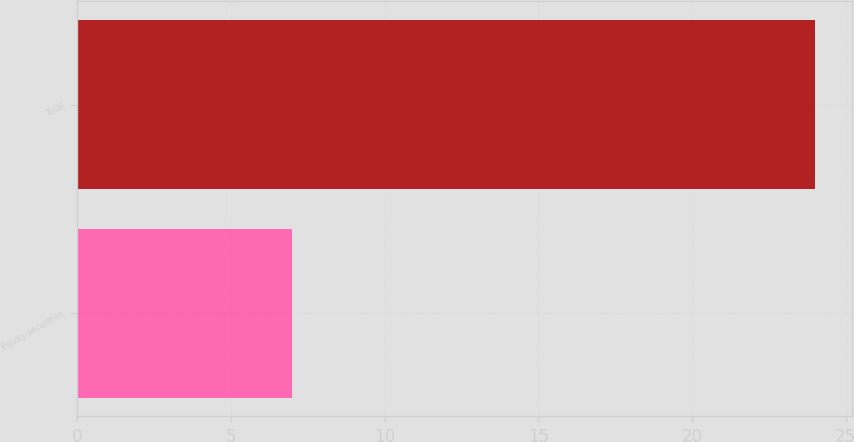Convert chart to OTSL. <chart><loc_0><loc_0><loc_500><loc_500><bar_chart><fcel>Equity securities<fcel>Total<nl><fcel>7<fcel>24<nl></chart> 